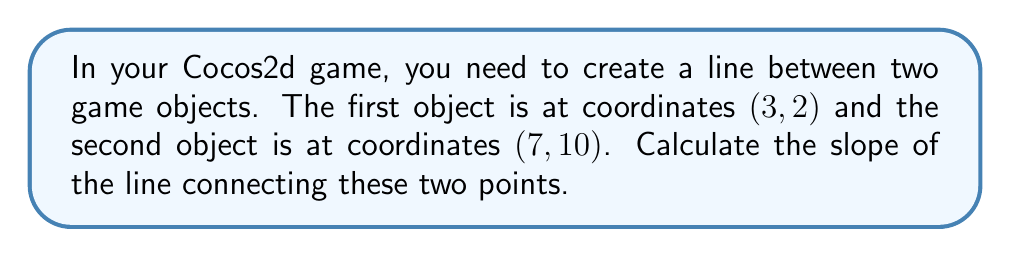Provide a solution to this math problem. To calculate the slope of a line given two points, we use the slope formula:

$$ m = \frac{y_2 - y_1}{x_2 - x_1} $$

Where $(x_1, y_1)$ is the first point and $(x_2, y_2)$ is the second point.

Given:
- Point 1: $(x_1, y_1) = (3, 2)$
- Point 2: $(x_2, y_2) = (7, 10)$

Let's substitute these values into the formula:

$$ m = \frac{10 - 2}{7 - 3} $$

Simplify:
$$ m = \frac{8}{4} $$

Reduce the fraction:
$$ m = 2 $$

Therefore, the slope of the line connecting the two game objects is 2.
Answer: $2$ 